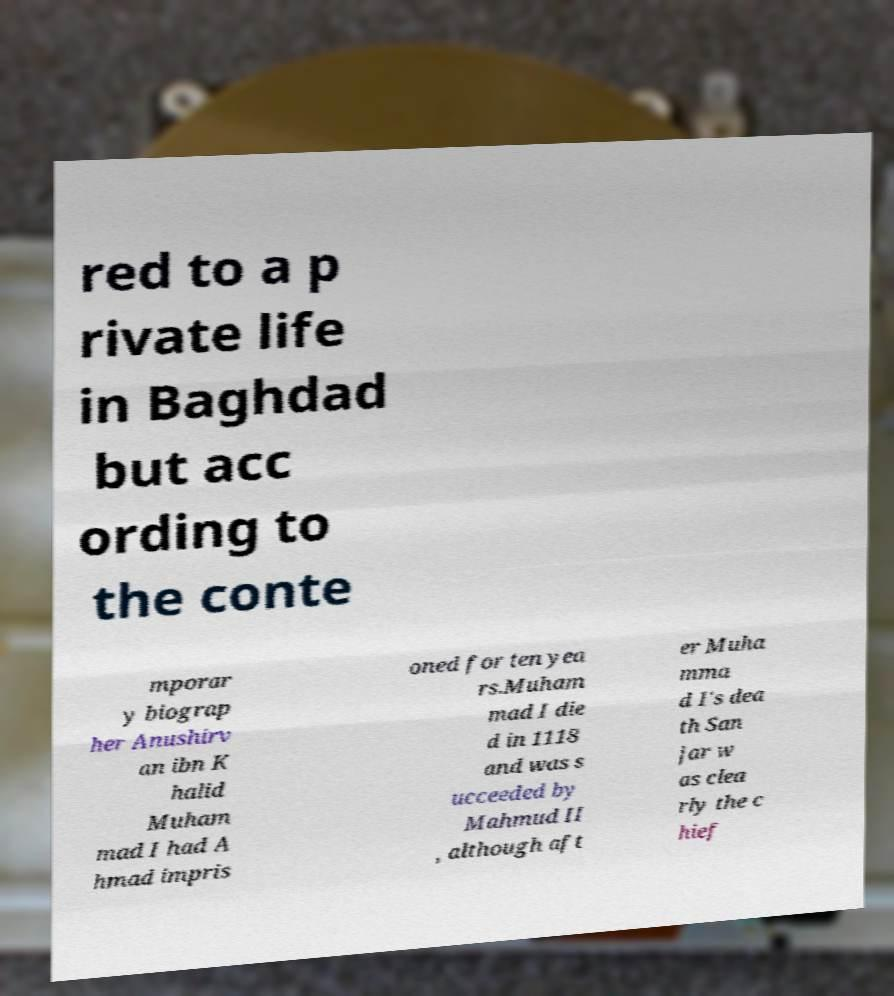There's text embedded in this image that I need extracted. Can you transcribe it verbatim? red to a p rivate life in Baghdad but acc ording to the conte mporar y biograp her Anushirv an ibn K halid Muham mad I had A hmad impris oned for ten yea rs.Muham mad I die d in 1118 and was s ucceeded by Mahmud II , although aft er Muha mma d I's dea th San jar w as clea rly the c hief 